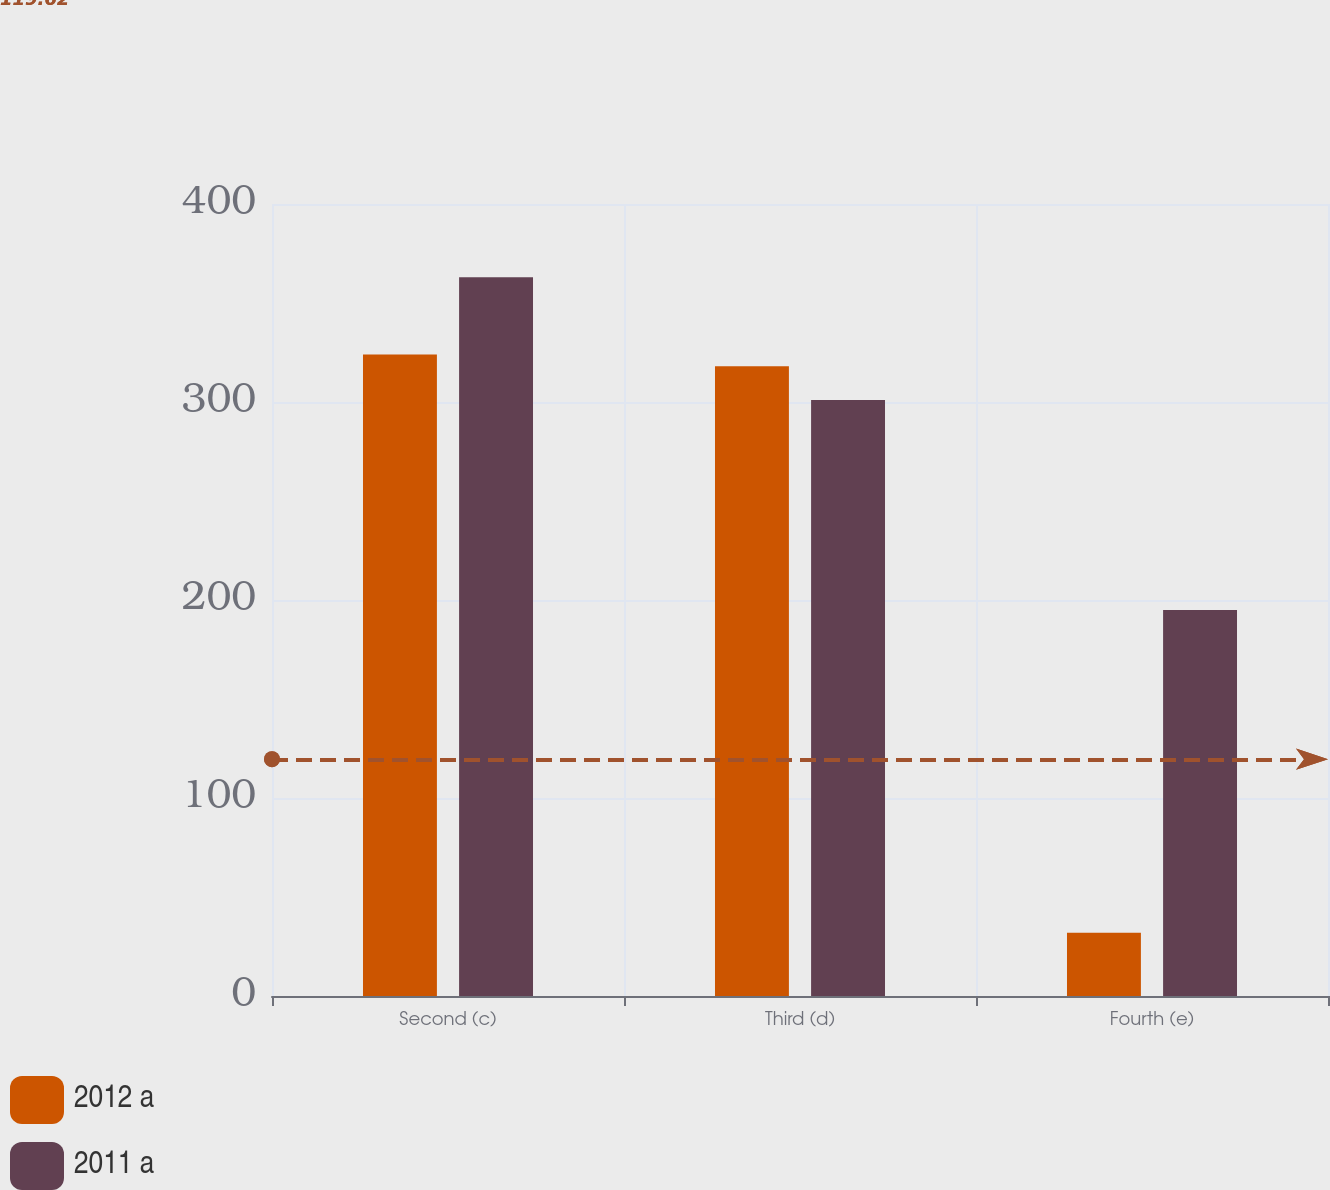Convert chart. <chart><loc_0><loc_0><loc_500><loc_500><stacked_bar_chart><ecel><fcel>Second (c)<fcel>Third (d)<fcel>Fourth (e)<nl><fcel>2012 a<fcel>324<fcel>318<fcel>32<nl><fcel>2011 a<fcel>363<fcel>301<fcel>195<nl></chart> 